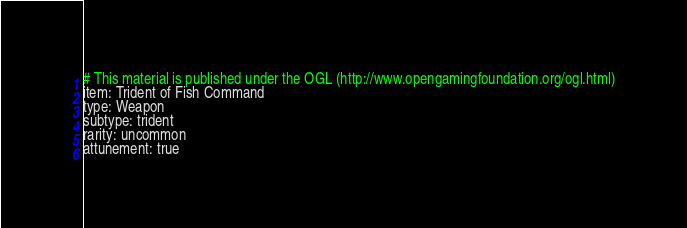Convert code to text. <code><loc_0><loc_0><loc_500><loc_500><_YAML_># This material is published under the OGL (http://www.opengamingfoundation.org/ogl.html)
item: Trident of Fish Command
type: Weapon
subtype: trident
rarity: uncommon
attunement: true
</code> 